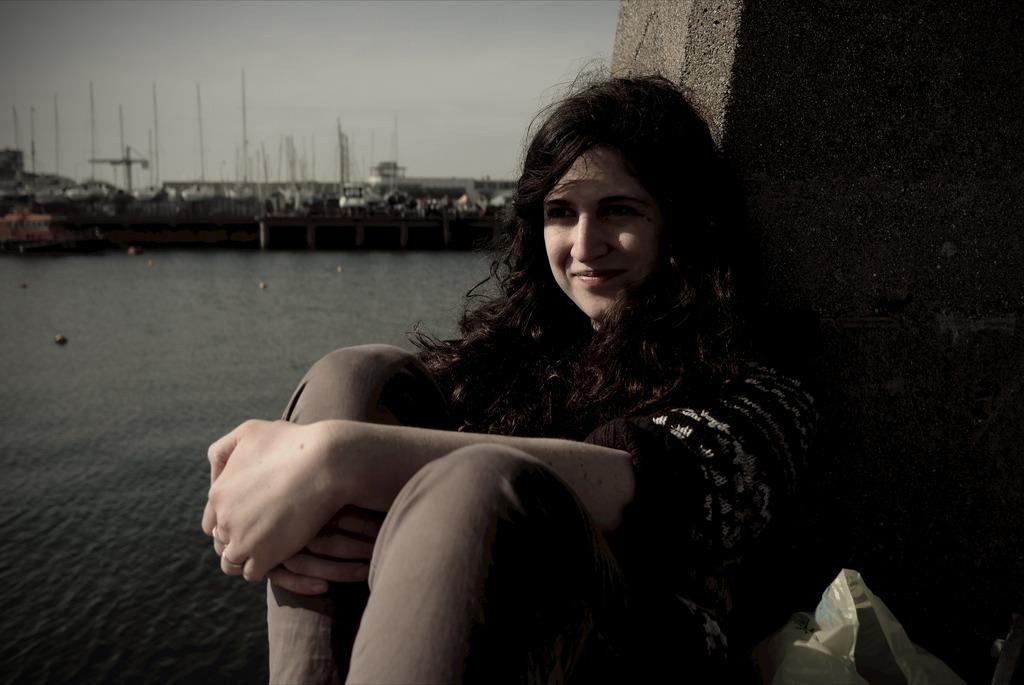Describe this image in one or two sentences. In the center of the image there is a woman sitting on the ground. In the background we can see water, bridge, harbor and sky. 